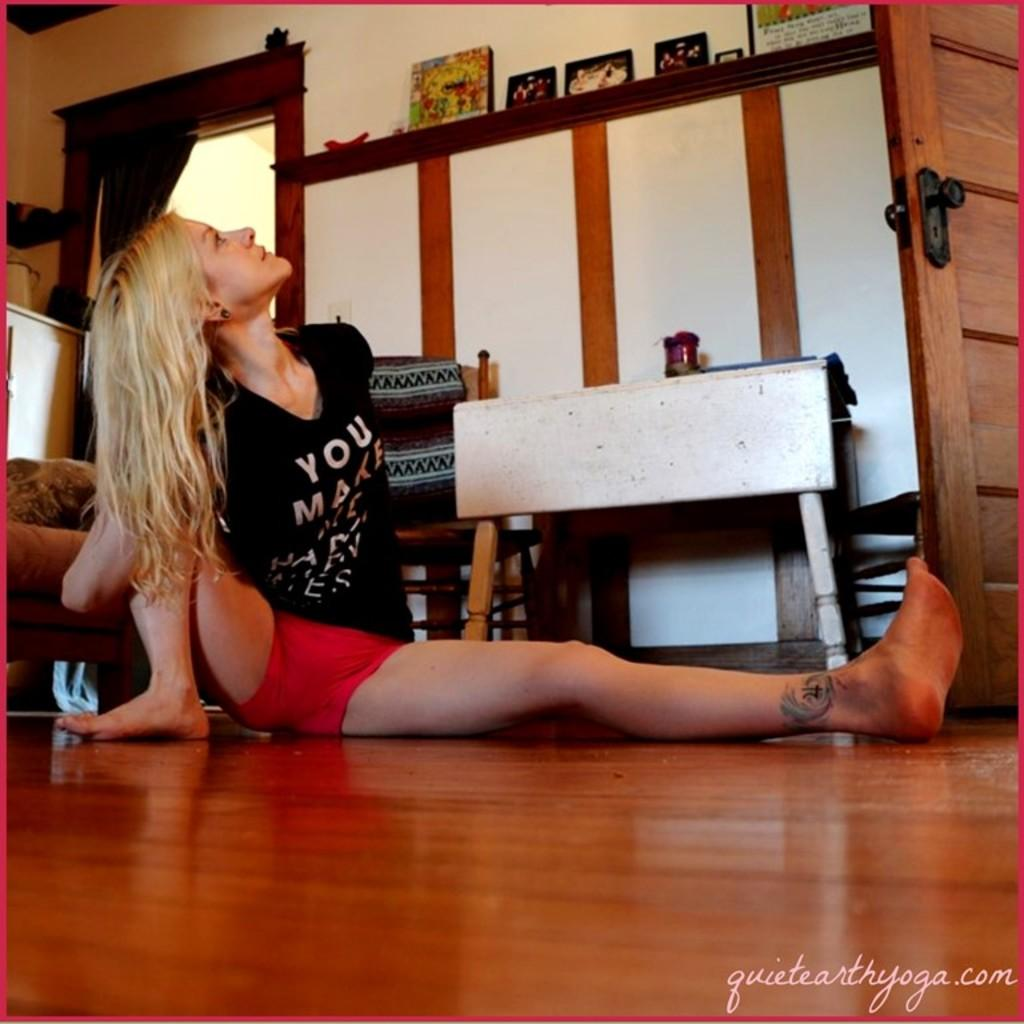<image>
Offer a succinct explanation of the picture presented. A woman wearing a black shirt that says you make looking up at the ceiling. 